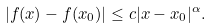Convert formula to latex. <formula><loc_0><loc_0><loc_500><loc_500>| f ( x ) - f ( x _ { 0 } ) | \leq c | x - x _ { 0 } | ^ { \alpha } .</formula> 